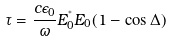Convert formula to latex. <formula><loc_0><loc_0><loc_500><loc_500>\tau = \frac { c \epsilon _ { 0 } } { \omega } E _ { 0 } ^ { ^ { * } } E _ { 0 } ( 1 - \cos \Delta )</formula> 